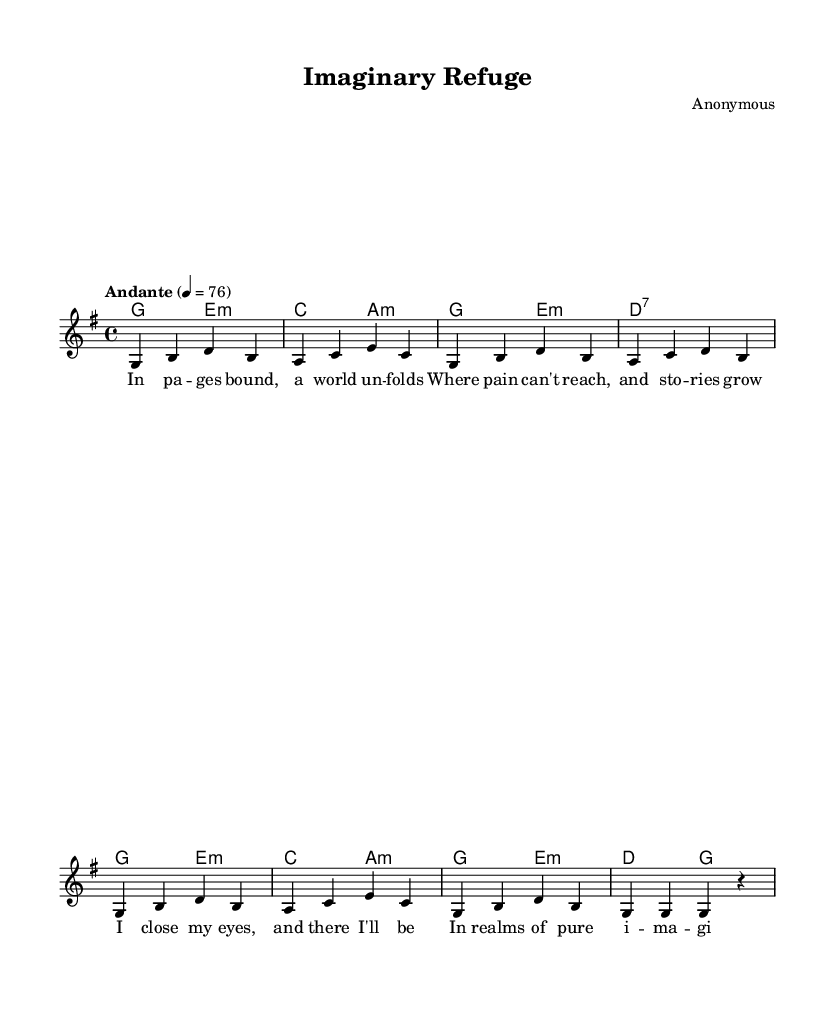What is the key signature of this music? The key signature in the piece is G major, which has one sharp (F#). This can be determined by looking at the key indicated at the start of the music, specifically listed as `\key g \major`.
Answer: G major What is the time signature of the piece? The time signature is 4/4, which indicates there are four beats in each measure and a quarter note receives one beat. This information can be found near the beginning of the music, shown as `\time 4/4`.
Answer: 4/4 What is the tempo marking of the music? The tempo marking is "Andante," followed by the metronome marking of 76 beats per minute. This is specified clearly in the music as `\tempo "Andante" 4 = 76`.
Answer: Andante, 76 How many measures are there in the piece? To determine the number of measures, one can count the distinct groupings within the melody and harmonies. In this case, there are eight measures when counted.
Answer: 8 What is the first lyric line in the song? The first lyric line can be found at the start of the lyrics section, displaying the words "In pages bound, a world unfolds." This is the text associated with the corresponding melody notes.
Answer: In pages bound, a world unfolds Which chords are used in the harmonies? The harmonies include the chords G, E minor, C, A minor, and D7. These are listed in sequence in the chord mode section and represent the foundation of the music.
Answer: G, E minor, C, A minor, D7 